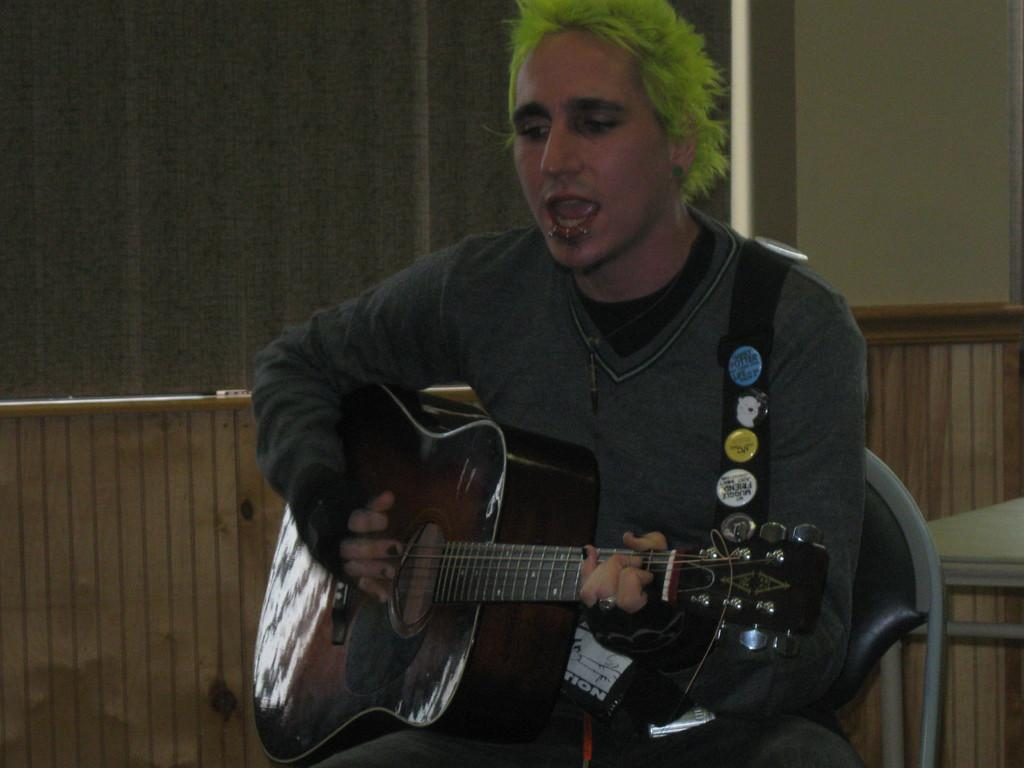Who is the main subject in the image? There is a man in the image. What is the man doing in the image? The man is seated on a chair, playing a guitar, and singing. What type of ladybug can be seen on the page of the man's music sheet in the image? There is no ladybug present on a music sheet or any other object in the image. 